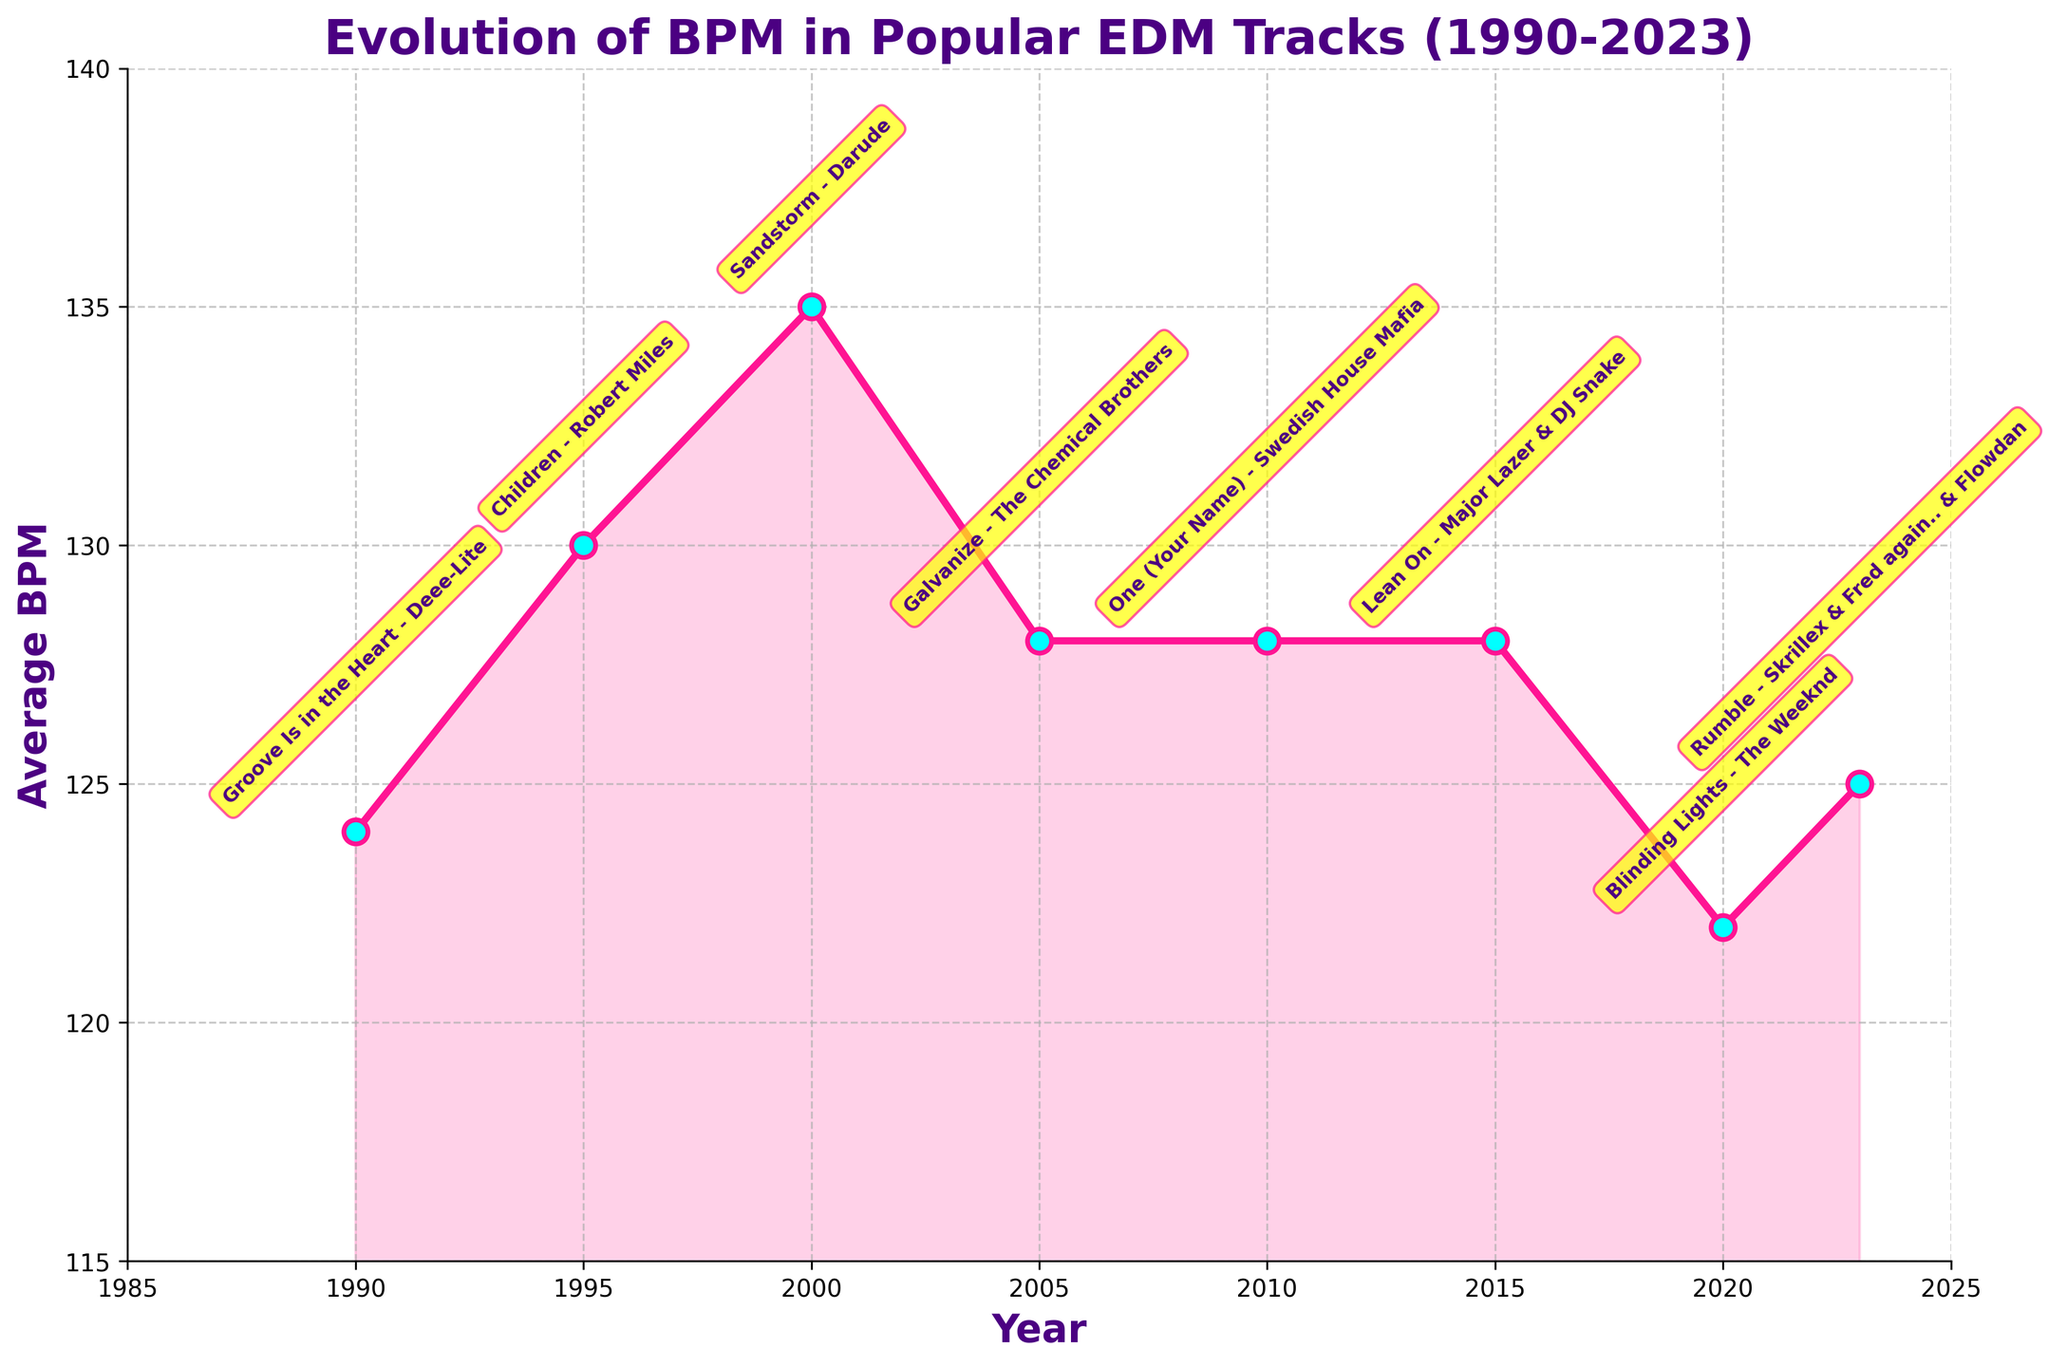What is the general trend in BPM from 1990 to 2023? To identify the general trend, observe the overall direction of the line. It appears to oscillate but roughly stabilizes around the 128 BPM mark from 2005 onwards with minor fluctuations.
Answer: Stabilizing around 128 BPM Which year had the highest average BPM? To find the highest point on the line chart, look for the peak value on the y-axis. The highest point on the chart is in the year 2000.
Answer: 2000 Compare the average BPM of 1990 and 2020. Locate the BPM values for the years 1990 and 2020 on the chart. In 1990, the BPM is 124, and in 2020, it is 122.
Answer: 124 and 122 Which year's average BPM is closer to 130: 1995 or 2023? Find and compare the BPM values for the years 1995 and 2023. The value for 1995 is 130, and for 2023, it is 125.
Answer: 1995 What color is used to fill the area under the BPM line? Look for the color filling the area under the line in the chart. It is shaded in a pinkish color.
Answer: Pinkish How many times did the average BPM remain at 128 BPM, and in which years? Identify the years where the average BPM values are exactly 128 by examining the line chart. It happens three times: in 2005, 2010, and 2015.
Answer: Three times: 2005, 2010, 2015 What was the average BPM difference between 2000 and 2010? Subtract the BPM value of 2010 from the value of 2000, which are 135 and 128 respectively.
Answer: 7 Which decade saw the highest increase in BPM? Compare the difference in BPM values for each decade: 1990-1999, 2000-2009, and so on. The largest increase occurs from 1990 (124 BPM) to 2000 (135 BPM).
Answer: 1990-2000 Identify the artist of the top track in 2020. Look for the annotation or text indication for the year 2020, which lists "Blinding Lights" by The Weeknd.
Answer: The Weeknd 